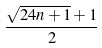Convert formula to latex. <formula><loc_0><loc_0><loc_500><loc_500>\frac { \sqrt { 2 4 n + 1 } + 1 } { 2 }</formula> 